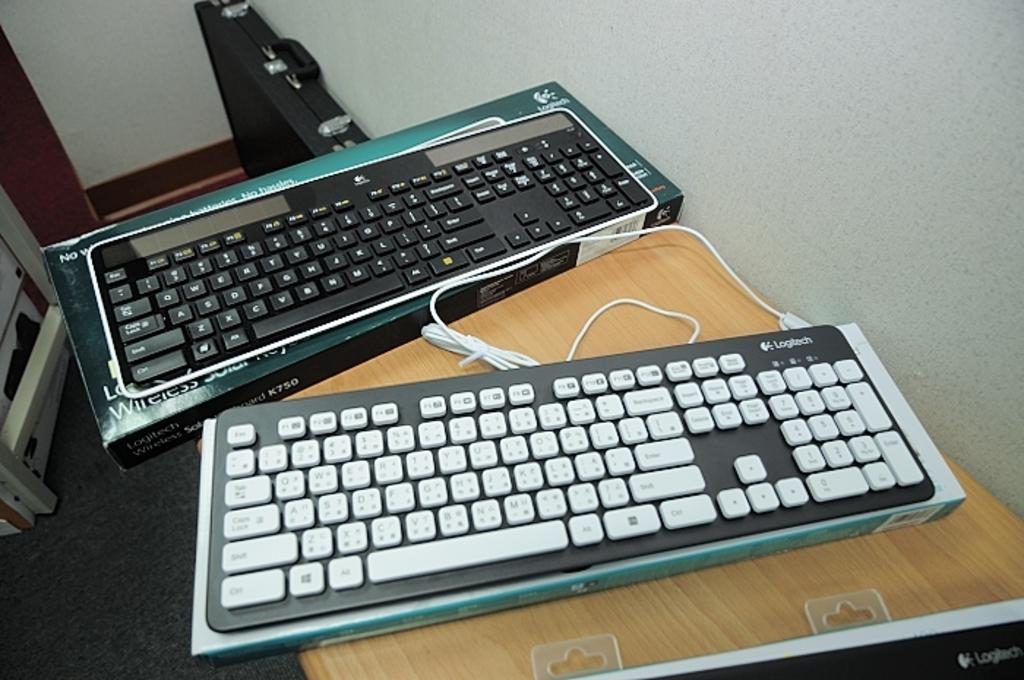How many keyboards are visible in the image? There are 2 keyboards in the image. What is placed under the keyboards? There are boxes under the keyboards. What can be seen in the background of the image? There is a suitcase and a wall in the background of the image. How much salt is present on the keyboards in the image? There is no salt present on the keyboards in the image. 